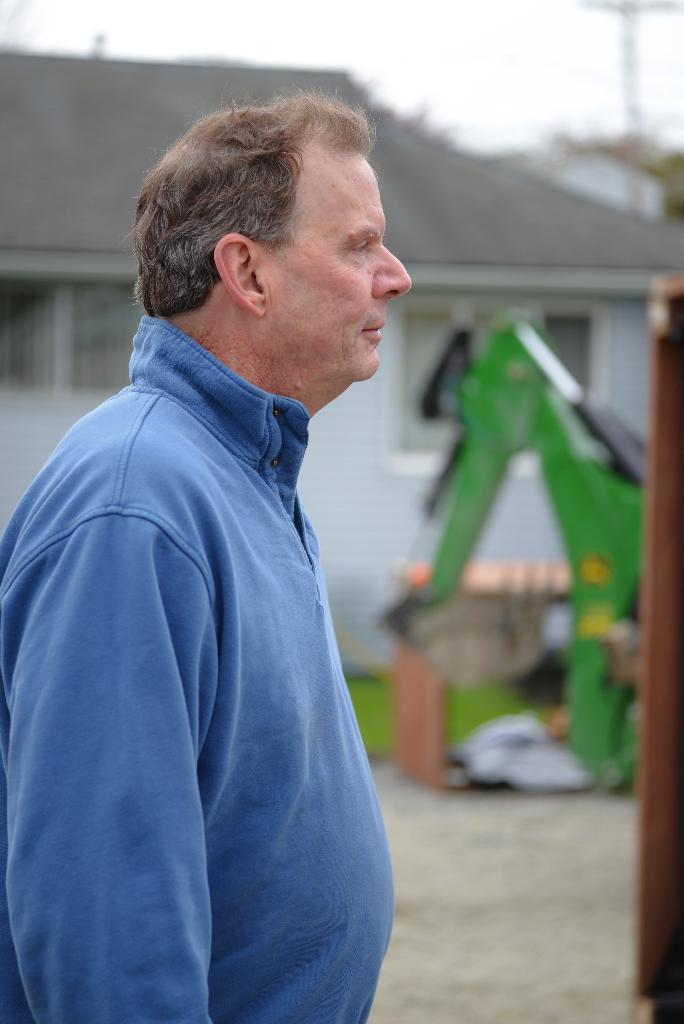Who is present in the image? There is a person in the image. What is the person wearing? The person is wearing a blue shirt. What is the person's posture in the image? The person is standing. What can be seen in the background of the image? There is a machine, a building with a roof, and the sky visible in the background of the image. What care instructions are provided for the machine in the image? There is no mention of care instructions for the machine in the image, as the focus is on the person and their appearance and posture. 